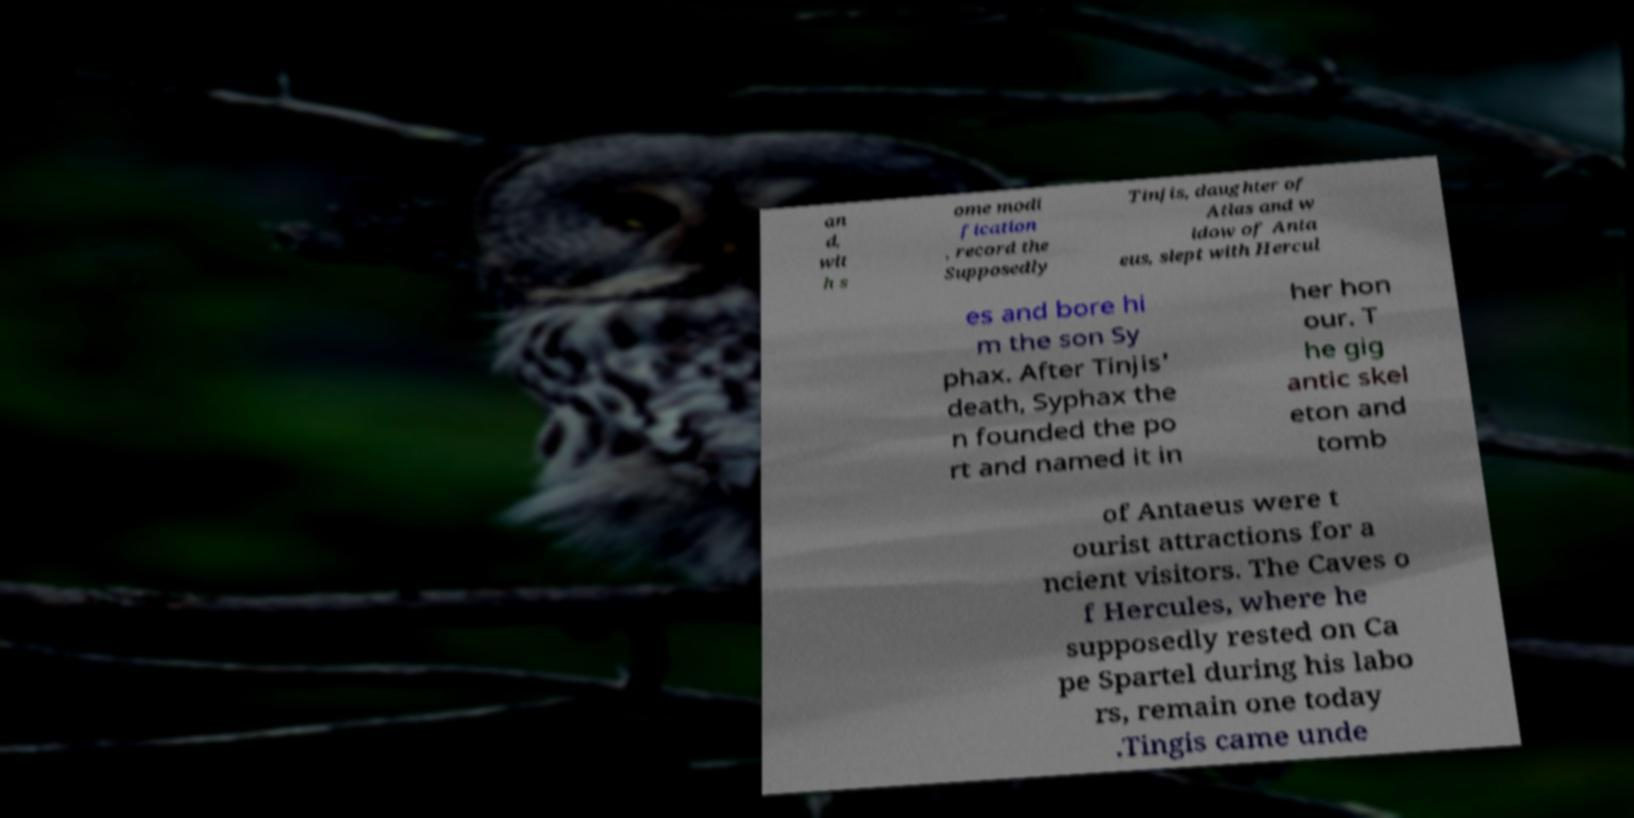I need the written content from this picture converted into text. Can you do that? an d, wit h s ome modi fication , record the Supposedly Tinjis, daughter of Atlas and w idow of Anta eus, slept with Hercul es and bore hi m the son Sy phax. After Tinjis' death, Syphax the n founded the po rt and named it in her hon our. T he gig antic skel eton and tomb of Antaeus were t ourist attractions for a ncient visitors. The Caves o f Hercules, where he supposedly rested on Ca pe Spartel during his labo rs, remain one today .Tingis came unde 